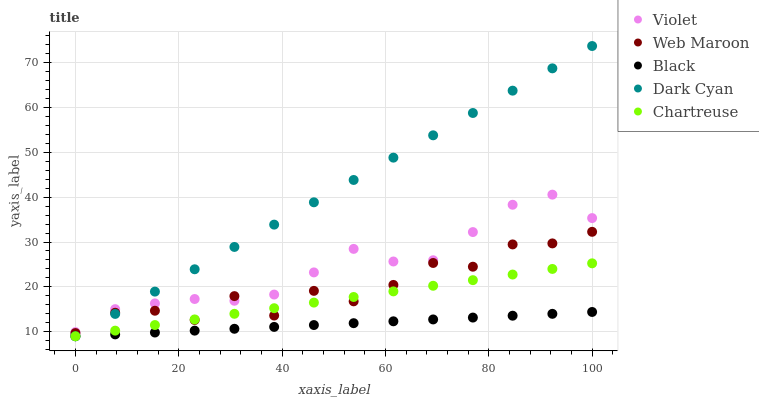Does Black have the minimum area under the curve?
Answer yes or no. Yes. Does Dark Cyan have the maximum area under the curve?
Answer yes or no. Yes. Does Chartreuse have the minimum area under the curve?
Answer yes or no. No. Does Chartreuse have the maximum area under the curve?
Answer yes or no. No. Is Black the smoothest?
Answer yes or no. Yes. Is Web Maroon the roughest?
Answer yes or no. Yes. Is Chartreuse the smoothest?
Answer yes or no. No. Is Chartreuse the roughest?
Answer yes or no. No. Does Dark Cyan have the lowest value?
Answer yes or no. Yes. Does Web Maroon have the lowest value?
Answer yes or no. No. Does Dark Cyan have the highest value?
Answer yes or no. Yes. Does Chartreuse have the highest value?
Answer yes or no. No. Is Black less than Violet?
Answer yes or no. Yes. Is Violet greater than Black?
Answer yes or no. Yes. Does Black intersect Chartreuse?
Answer yes or no. Yes. Is Black less than Chartreuse?
Answer yes or no. No. Is Black greater than Chartreuse?
Answer yes or no. No. Does Black intersect Violet?
Answer yes or no. No. 